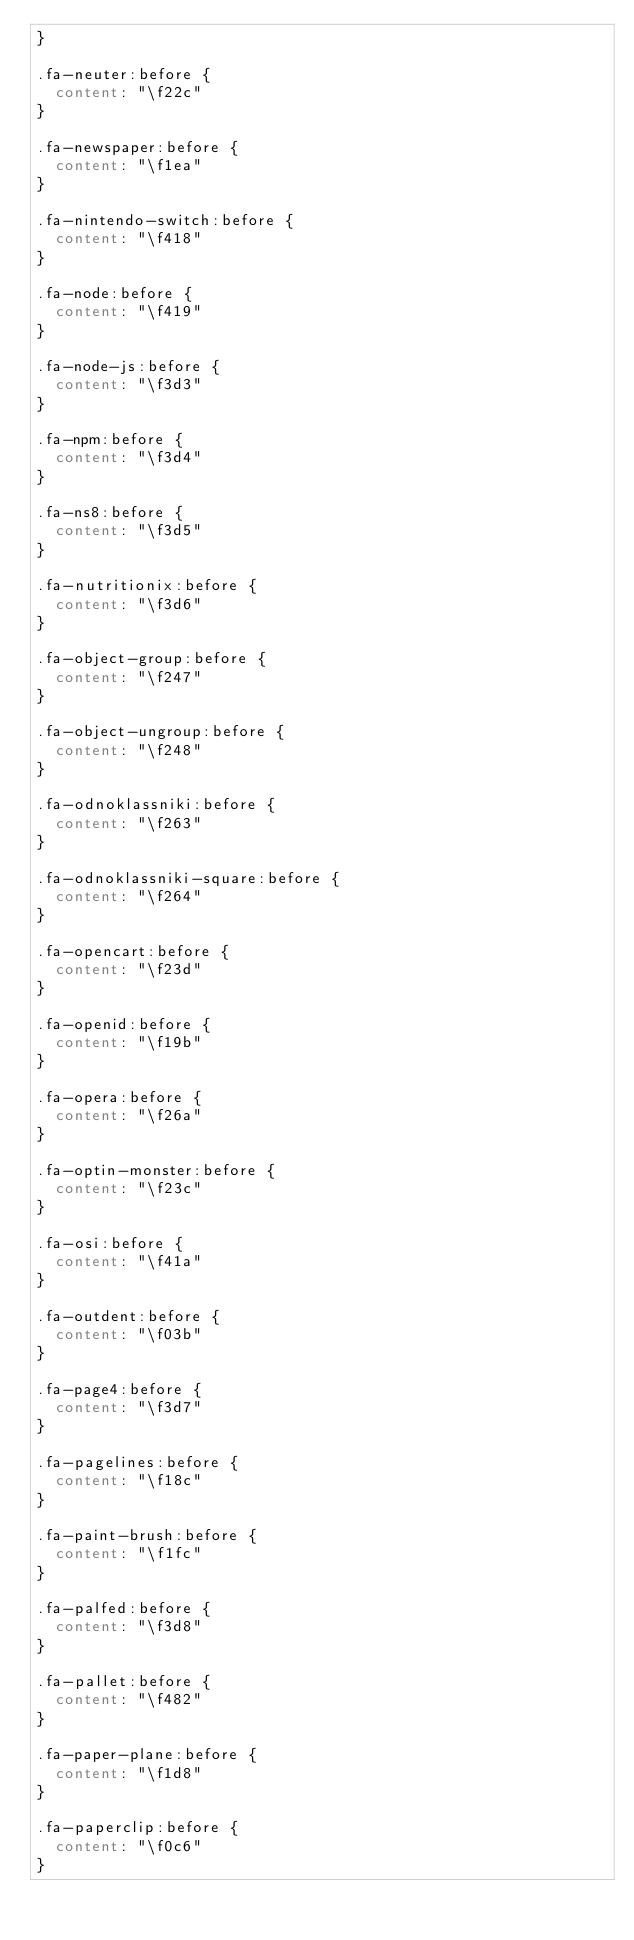Convert code to text. <code><loc_0><loc_0><loc_500><loc_500><_CSS_>}

.fa-neuter:before {
	content: "\f22c"
}

.fa-newspaper:before {
	content: "\f1ea"
}

.fa-nintendo-switch:before {
	content: "\f418"
}

.fa-node:before {
	content: "\f419"
}

.fa-node-js:before {
	content: "\f3d3"
}

.fa-npm:before {
	content: "\f3d4"
}

.fa-ns8:before {
	content: "\f3d5"
}

.fa-nutritionix:before {
	content: "\f3d6"
}

.fa-object-group:before {
	content: "\f247"
}

.fa-object-ungroup:before {
	content: "\f248"
}

.fa-odnoklassniki:before {
	content: "\f263"
}

.fa-odnoklassniki-square:before {
	content: "\f264"
}

.fa-opencart:before {
	content: "\f23d"
}

.fa-openid:before {
	content: "\f19b"
}

.fa-opera:before {
	content: "\f26a"
}

.fa-optin-monster:before {
	content: "\f23c"
}

.fa-osi:before {
	content: "\f41a"
}

.fa-outdent:before {
	content: "\f03b"
}

.fa-page4:before {
	content: "\f3d7"
}

.fa-pagelines:before {
	content: "\f18c"
}

.fa-paint-brush:before {
	content: "\f1fc"
}

.fa-palfed:before {
	content: "\f3d8"
}

.fa-pallet:before {
	content: "\f482"
}

.fa-paper-plane:before {
	content: "\f1d8"
}

.fa-paperclip:before {
	content: "\f0c6"
}
</code> 